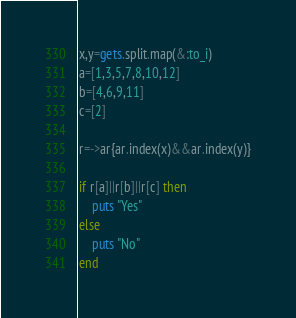Convert code to text. <code><loc_0><loc_0><loc_500><loc_500><_Ruby_>x,y=gets.split.map(&:to_i)
a=[1,3,5,7,8,10,12]
b=[4,6,9,11]
c=[2]

r=->ar{ar.index(x)&&ar.index(y)}

if r[a]||r[b]||r[c] then
    puts "Yes"
else
    puts "No"
end</code> 